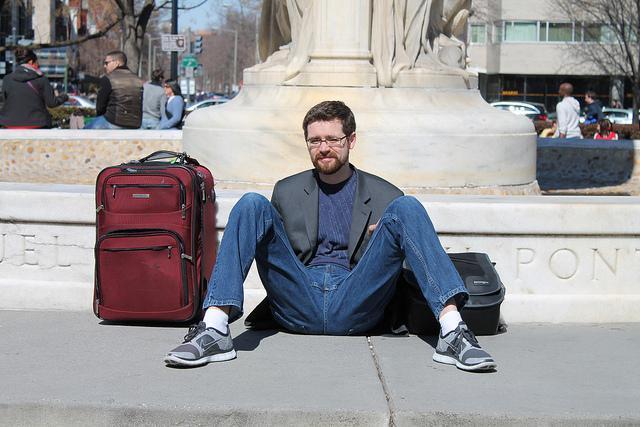How many suitcases are in the picture?
Give a very brief answer. 2. How many people are there?
Give a very brief answer. 3. 